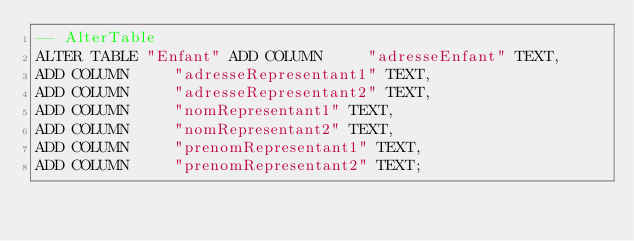<code> <loc_0><loc_0><loc_500><loc_500><_SQL_>-- AlterTable
ALTER TABLE "Enfant" ADD COLUMN     "adresseEnfant" TEXT,
ADD COLUMN     "adresseRepresentant1" TEXT,
ADD COLUMN     "adresseRepresentant2" TEXT,
ADD COLUMN     "nomRepresentant1" TEXT,
ADD COLUMN     "nomRepresentant2" TEXT,
ADD COLUMN     "prenomRepresentant1" TEXT,
ADD COLUMN     "prenomRepresentant2" TEXT;
</code> 